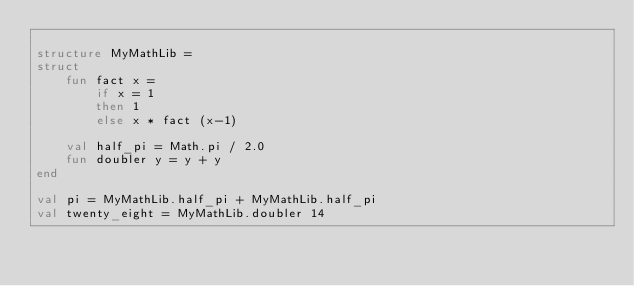<code> <loc_0><loc_0><loc_500><loc_500><_SML_>
structure MyMathLib =
struct
    fun fact x =
        if x = 1
        then 1
        else x * fact (x-1)

    val half_pi = Math.pi / 2.0
    fun doubler y = y + y
end

val pi = MyMathLib.half_pi + MyMathLib.half_pi
val twenty_eight = MyMathLib.doubler 14</code> 